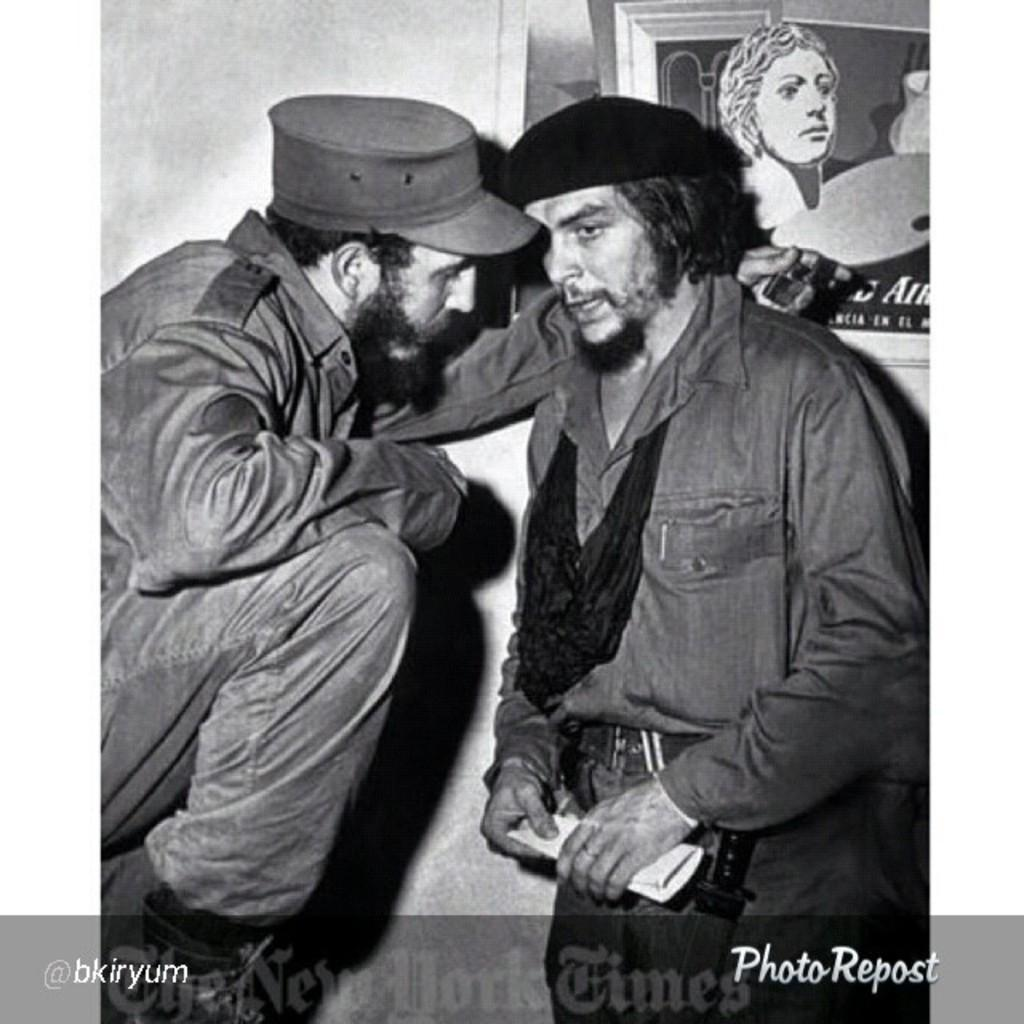Who are the two famous personalities in the image? The two personalities in the image are not specified, but they are famous. What are the two personalities doing in the image? The two personalities are talking with each other in the image. What can be seen in the background of the image? There is a frame and a wall in the background of the image. What is present at the bottom of the image? There is text at the bottom of the image. What type of cracker is being used as a prop in the image? There is no cracker present in the image. What country are the two personalities from in the image? The nationalities of the two personalities are not specified in the image. 